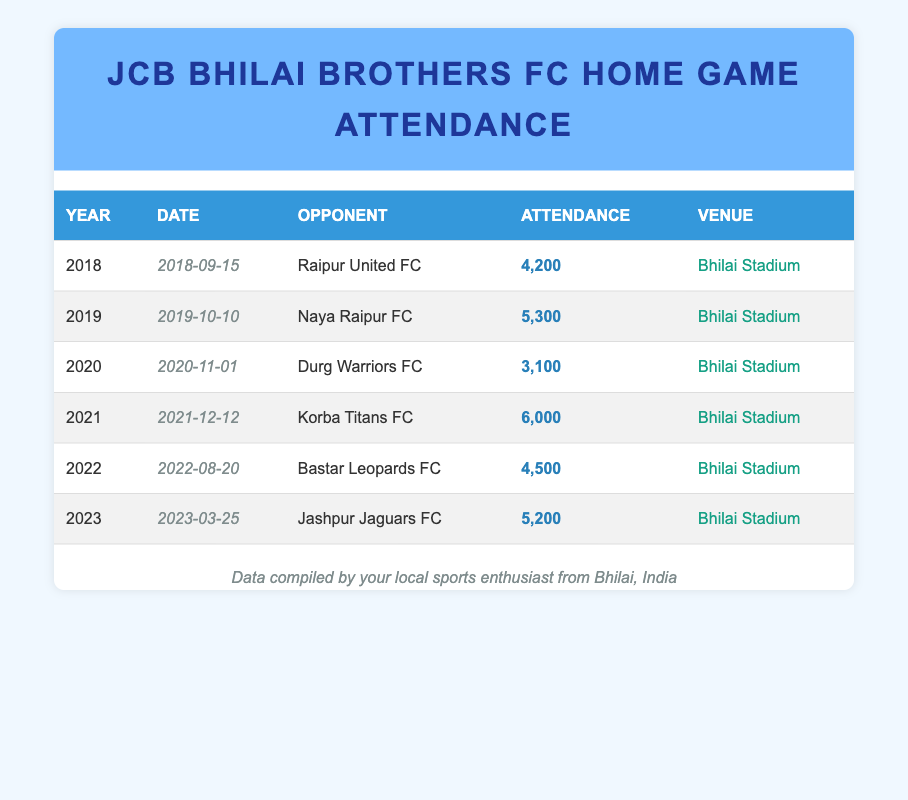What was the highest attendance recorded for JCB Bhilai Brothers FC home games? The highest attendance was recorded in 2021 for the match against Korba Titans FC, with 6000 attendees.
Answer: 6000 Which year had the lowest attendance? The lowest attendance was in 2020 during the match against Durg Warriors FC, which had 3100 attendees.
Answer: 2020 How many times did the attendance exceed 5000 in the last five years? The attendance exceeded 5000 in the years 2019 (5300), 2021 (6000), and 2023 (5200), totaling three instances.
Answer: 3 What is the average attendance across all years? To find the average, sum the attendance: (4200 + 5300 + 3100 + 6000 + 4500 + 5200) = 28300. Since there are 6 matches, divide by 6: 28300 / 6 = 4716.67, which rounds to approximately 4717.
Answer: 4717 Did JCB Bhilai Brothers FC play more home games in odd years than in even years? They played three matches in odd years (2019, 2021, 2023) and three in even years (2018, 2020, 2022), meaning they did not play more in odd years.
Answer: No What was the attendance at the match against Bastar Leopards FC? The attendance for the match against Bastar Leopards FC on August 20, 2022, was 4500.
Answer: 4500 Which match had an attendance that was exactly 200 attendees less than the match against Naya Raipur FC? The match against Naya Raipur FC had an attendance of 5300, so 200 less would be 5100. However, only the match against Jashpur Jaguars FC had an attendance of 5200, which is the closest but not exactly 5100.
Answer: No match How does the attendance in 2022 compare to the attendance in 2020? In 2022, the attendance was 4500, and in 2020, it was 3100. Subtracting the two gives 4500 - 3100 = 1400, indicating that the attendance in 2022 was significantly higher by 1400.
Answer: Higher by 1400 Was there a match where the attendance was exactly 4200? Yes, the match against Raipur United FC in 2018 recorded an attendance of exactly 4200.
Answer: Yes 